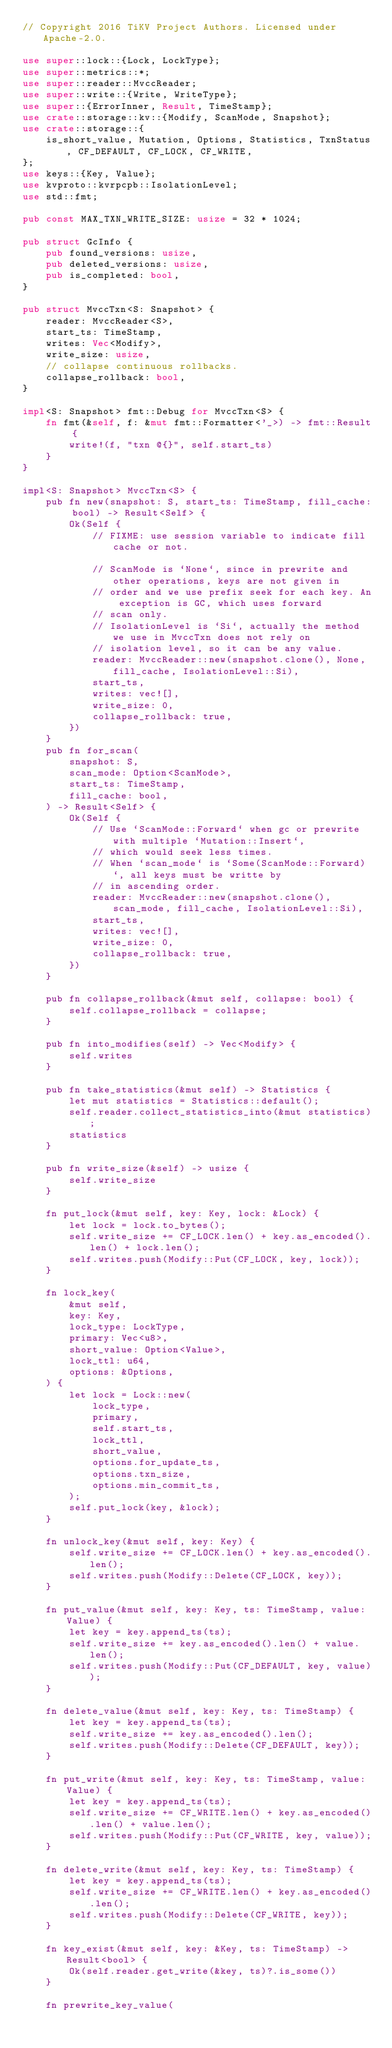<code> <loc_0><loc_0><loc_500><loc_500><_Rust_>// Copyright 2016 TiKV Project Authors. Licensed under Apache-2.0.

use super::lock::{Lock, LockType};
use super::metrics::*;
use super::reader::MvccReader;
use super::write::{Write, WriteType};
use super::{ErrorInner, Result, TimeStamp};
use crate::storage::kv::{Modify, ScanMode, Snapshot};
use crate::storage::{
    is_short_value, Mutation, Options, Statistics, TxnStatus, CF_DEFAULT, CF_LOCK, CF_WRITE,
};
use keys::{Key, Value};
use kvproto::kvrpcpb::IsolationLevel;
use std::fmt;

pub const MAX_TXN_WRITE_SIZE: usize = 32 * 1024;

pub struct GcInfo {
    pub found_versions: usize,
    pub deleted_versions: usize,
    pub is_completed: bool,
}

pub struct MvccTxn<S: Snapshot> {
    reader: MvccReader<S>,
    start_ts: TimeStamp,
    writes: Vec<Modify>,
    write_size: usize,
    // collapse continuous rollbacks.
    collapse_rollback: bool,
}

impl<S: Snapshot> fmt::Debug for MvccTxn<S> {
    fn fmt(&self, f: &mut fmt::Formatter<'_>) -> fmt::Result {
        write!(f, "txn @{}", self.start_ts)
    }
}

impl<S: Snapshot> MvccTxn<S> {
    pub fn new(snapshot: S, start_ts: TimeStamp, fill_cache: bool) -> Result<Self> {
        Ok(Self {
            // FIXME: use session variable to indicate fill cache or not.

            // ScanMode is `None`, since in prewrite and other operations, keys are not given in
            // order and we use prefix seek for each key. An exception is GC, which uses forward
            // scan only.
            // IsolationLevel is `Si`, actually the method we use in MvccTxn does not rely on
            // isolation level, so it can be any value.
            reader: MvccReader::new(snapshot.clone(), None, fill_cache, IsolationLevel::Si),
            start_ts,
            writes: vec![],
            write_size: 0,
            collapse_rollback: true,
        })
    }
    pub fn for_scan(
        snapshot: S,
        scan_mode: Option<ScanMode>,
        start_ts: TimeStamp,
        fill_cache: bool,
    ) -> Result<Self> {
        Ok(Self {
            // Use `ScanMode::Forward` when gc or prewrite with multiple `Mutation::Insert`,
            // which would seek less times.
            // When `scan_mode` is `Some(ScanMode::Forward)`, all keys must be writte by
            // in ascending order.
            reader: MvccReader::new(snapshot.clone(), scan_mode, fill_cache, IsolationLevel::Si),
            start_ts,
            writes: vec![],
            write_size: 0,
            collapse_rollback: true,
        })
    }

    pub fn collapse_rollback(&mut self, collapse: bool) {
        self.collapse_rollback = collapse;
    }

    pub fn into_modifies(self) -> Vec<Modify> {
        self.writes
    }

    pub fn take_statistics(&mut self) -> Statistics {
        let mut statistics = Statistics::default();
        self.reader.collect_statistics_into(&mut statistics);
        statistics
    }

    pub fn write_size(&self) -> usize {
        self.write_size
    }

    fn put_lock(&mut self, key: Key, lock: &Lock) {
        let lock = lock.to_bytes();
        self.write_size += CF_LOCK.len() + key.as_encoded().len() + lock.len();
        self.writes.push(Modify::Put(CF_LOCK, key, lock));
    }

    fn lock_key(
        &mut self,
        key: Key,
        lock_type: LockType,
        primary: Vec<u8>,
        short_value: Option<Value>,
        lock_ttl: u64,
        options: &Options,
    ) {
        let lock = Lock::new(
            lock_type,
            primary,
            self.start_ts,
            lock_ttl,
            short_value,
            options.for_update_ts,
            options.txn_size,
            options.min_commit_ts,
        );
        self.put_lock(key, &lock);
    }

    fn unlock_key(&mut self, key: Key) {
        self.write_size += CF_LOCK.len() + key.as_encoded().len();
        self.writes.push(Modify::Delete(CF_LOCK, key));
    }

    fn put_value(&mut self, key: Key, ts: TimeStamp, value: Value) {
        let key = key.append_ts(ts);
        self.write_size += key.as_encoded().len() + value.len();
        self.writes.push(Modify::Put(CF_DEFAULT, key, value));
    }

    fn delete_value(&mut self, key: Key, ts: TimeStamp) {
        let key = key.append_ts(ts);
        self.write_size += key.as_encoded().len();
        self.writes.push(Modify::Delete(CF_DEFAULT, key));
    }

    fn put_write(&mut self, key: Key, ts: TimeStamp, value: Value) {
        let key = key.append_ts(ts);
        self.write_size += CF_WRITE.len() + key.as_encoded().len() + value.len();
        self.writes.push(Modify::Put(CF_WRITE, key, value));
    }

    fn delete_write(&mut self, key: Key, ts: TimeStamp) {
        let key = key.append_ts(ts);
        self.write_size += CF_WRITE.len() + key.as_encoded().len();
        self.writes.push(Modify::Delete(CF_WRITE, key));
    }

    fn key_exist(&mut self, key: &Key, ts: TimeStamp) -> Result<bool> {
        Ok(self.reader.get_write(&key, ts)?.is_some())
    }

    fn prewrite_key_value(</code> 